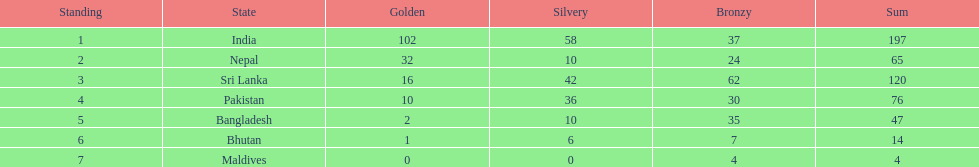How many more gold medals has nepal won than pakistan? 22. 